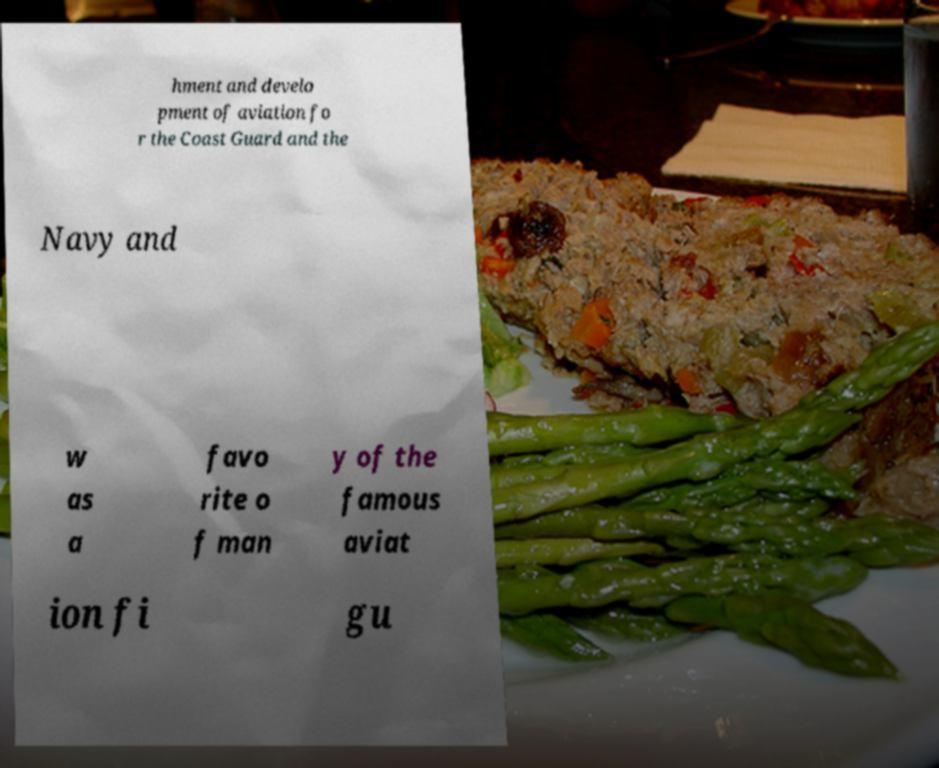Could you extract and type out the text from this image? hment and develo pment of aviation fo r the Coast Guard and the Navy and w as a favo rite o f man y of the famous aviat ion fi gu 